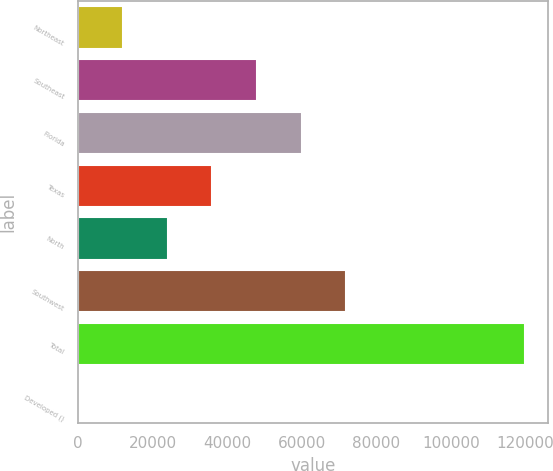<chart> <loc_0><loc_0><loc_500><loc_500><bar_chart><fcel>Northeast<fcel>Southeast<fcel>Florida<fcel>Texas<fcel>North<fcel>Southwest<fcel>Total<fcel>Developed ()<nl><fcel>12012.7<fcel>47966.8<fcel>59951.5<fcel>35982.1<fcel>23997.4<fcel>71936.2<fcel>119875<fcel>28<nl></chart> 